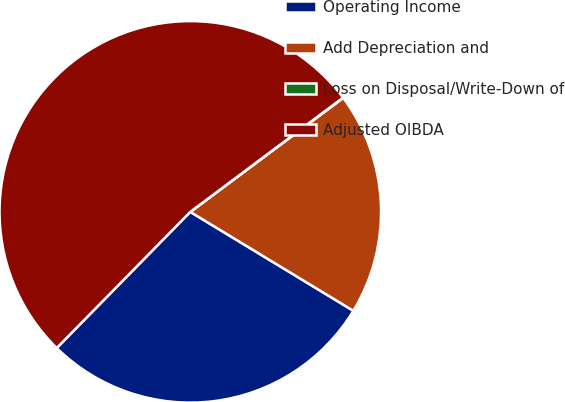Convert chart. <chart><loc_0><loc_0><loc_500><loc_500><pie_chart><fcel>Operating Income<fcel>Add Depreciation and<fcel>Loss on Disposal/Write-Down of<fcel>Adjusted OIBDA<nl><fcel>28.67%<fcel>18.87%<fcel>0.03%<fcel>52.43%<nl></chart> 